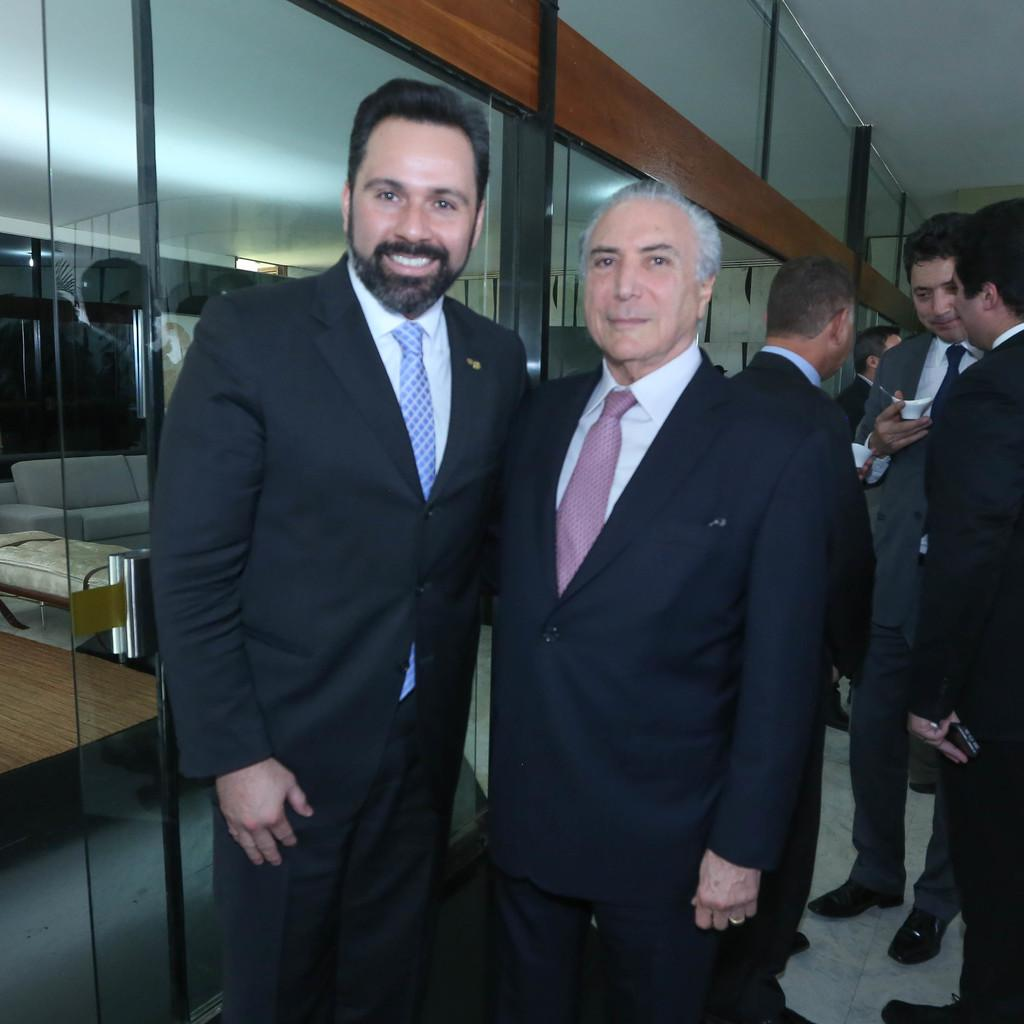How many people can be seen in the image? There are many people standing in the image. What is located on the left side of the image? There is a glass wall on the left side of the image. What can be seen through the glass wall? Some sofas are visible through the glass wall. Can you tell me how many donkeys are present in the image? There are no donkeys present in the image. What are the people learning in the image? The image does not provide information about what the people might be learning. 